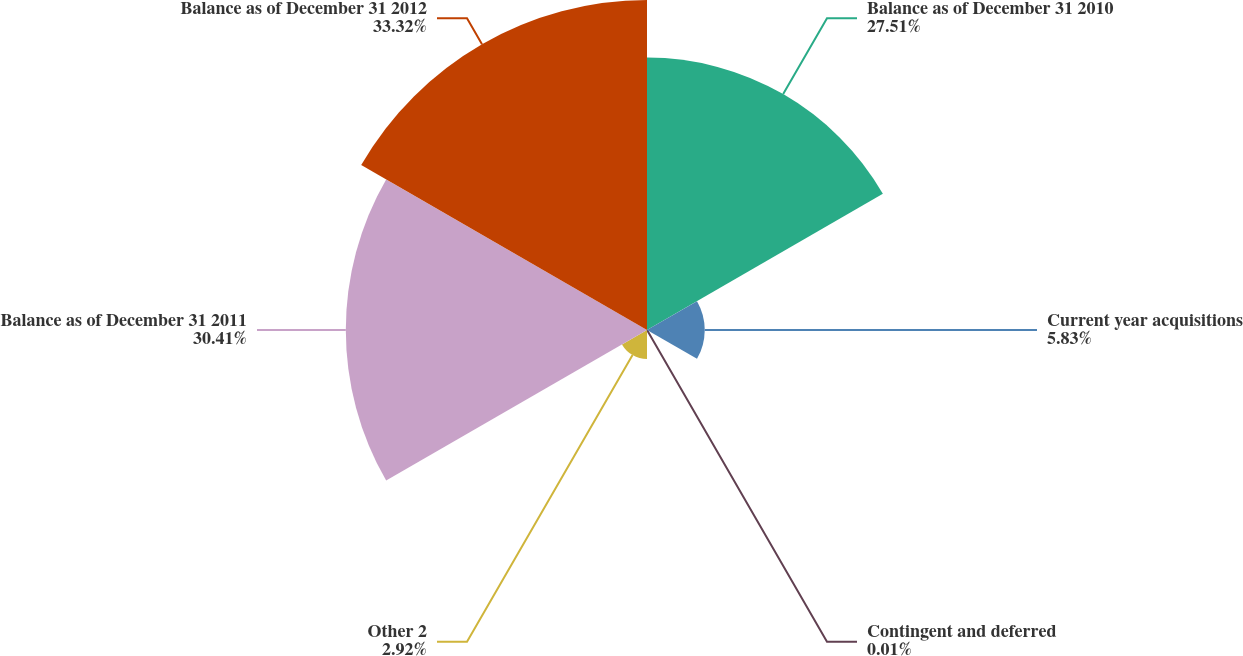Convert chart. <chart><loc_0><loc_0><loc_500><loc_500><pie_chart><fcel>Balance as of December 31 2010<fcel>Current year acquisitions<fcel>Contingent and deferred<fcel>Other 2<fcel>Balance as of December 31 2011<fcel>Balance as of December 31 2012<nl><fcel>27.51%<fcel>5.83%<fcel>0.01%<fcel>2.92%<fcel>30.42%<fcel>33.33%<nl></chart> 